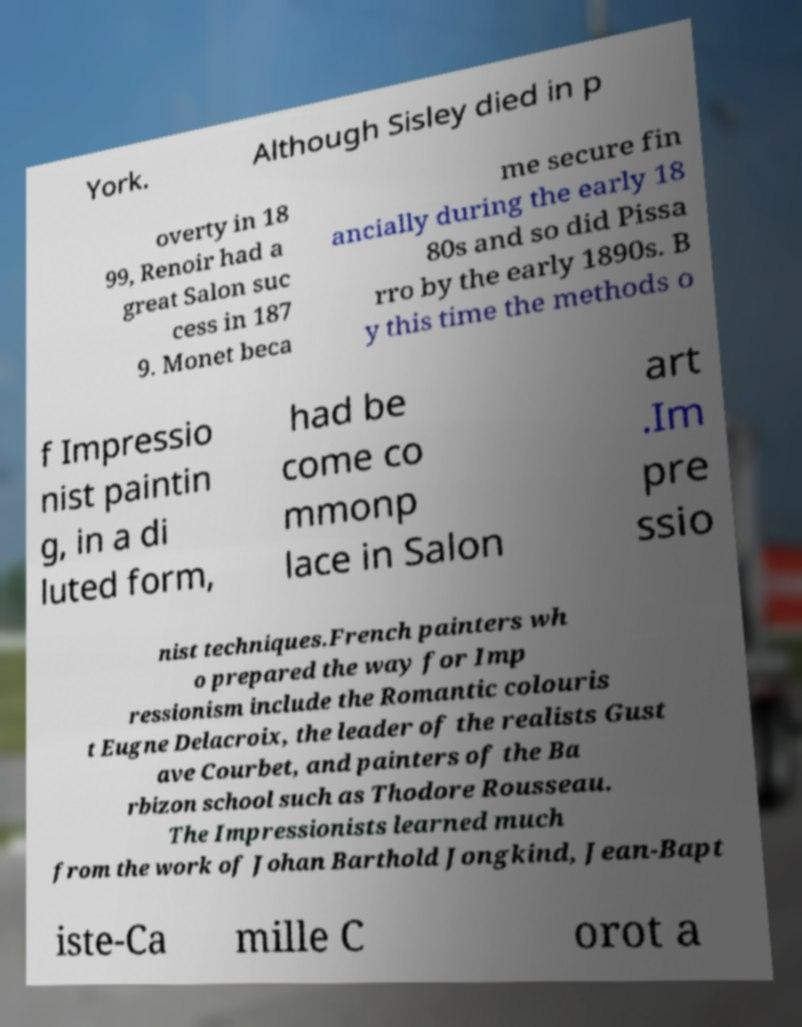Could you extract and type out the text from this image? York. Although Sisley died in p overty in 18 99, Renoir had a great Salon suc cess in 187 9. Monet beca me secure fin ancially during the early 18 80s and so did Pissa rro by the early 1890s. B y this time the methods o f Impressio nist paintin g, in a di luted form, had be come co mmonp lace in Salon art .Im pre ssio nist techniques.French painters wh o prepared the way for Imp ressionism include the Romantic colouris t Eugne Delacroix, the leader of the realists Gust ave Courbet, and painters of the Ba rbizon school such as Thodore Rousseau. The Impressionists learned much from the work of Johan Barthold Jongkind, Jean-Bapt iste-Ca mille C orot a 